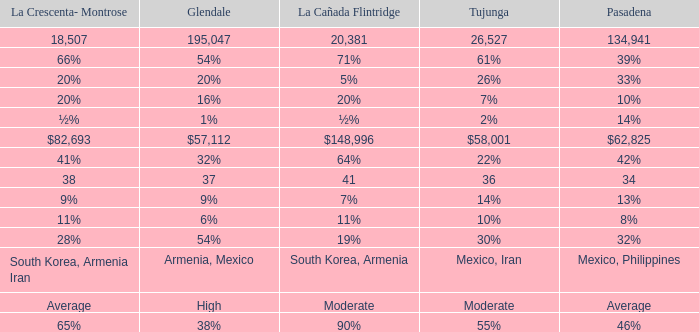What is the percentage of Glendale when La Canada Flintridge is 5%? 20%. 